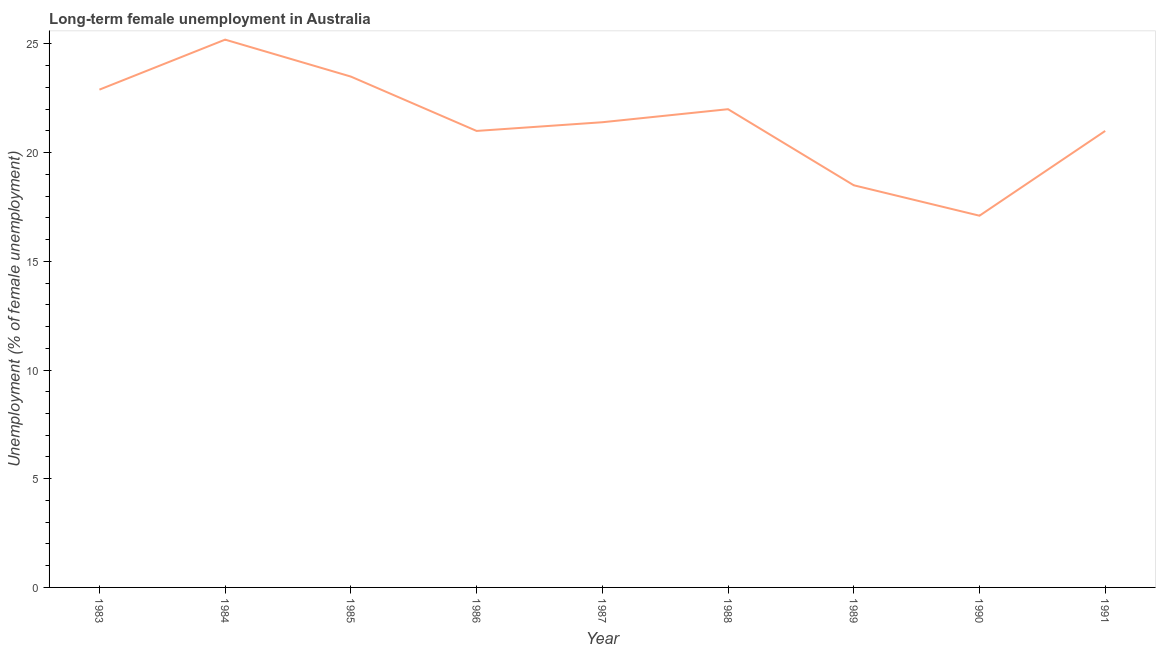What is the long-term female unemployment in 1987?
Your answer should be compact. 21.4. Across all years, what is the maximum long-term female unemployment?
Offer a terse response. 25.2. Across all years, what is the minimum long-term female unemployment?
Your answer should be very brief. 17.1. In which year was the long-term female unemployment maximum?
Provide a succinct answer. 1984. In which year was the long-term female unemployment minimum?
Your answer should be very brief. 1990. What is the sum of the long-term female unemployment?
Make the answer very short. 192.6. What is the difference between the long-term female unemployment in 1984 and 1989?
Provide a short and direct response. 6.7. What is the average long-term female unemployment per year?
Your answer should be compact. 21.4. What is the median long-term female unemployment?
Offer a terse response. 21.4. What is the ratio of the long-term female unemployment in 1986 to that in 1987?
Your answer should be compact. 0.98. What is the difference between the highest and the second highest long-term female unemployment?
Keep it short and to the point. 1.7. What is the difference between the highest and the lowest long-term female unemployment?
Offer a terse response. 8.1. Does the long-term female unemployment monotonically increase over the years?
Give a very brief answer. No. How many lines are there?
Offer a very short reply. 1. How many years are there in the graph?
Make the answer very short. 9. What is the difference between two consecutive major ticks on the Y-axis?
Your response must be concise. 5. Does the graph contain grids?
Keep it short and to the point. No. What is the title of the graph?
Your response must be concise. Long-term female unemployment in Australia. What is the label or title of the X-axis?
Your response must be concise. Year. What is the label or title of the Y-axis?
Your response must be concise. Unemployment (% of female unemployment). What is the Unemployment (% of female unemployment) of 1983?
Offer a terse response. 22.9. What is the Unemployment (% of female unemployment) in 1984?
Provide a short and direct response. 25.2. What is the Unemployment (% of female unemployment) of 1986?
Keep it short and to the point. 21. What is the Unemployment (% of female unemployment) of 1987?
Keep it short and to the point. 21.4. What is the Unemployment (% of female unemployment) in 1989?
Provide a short and direct response. 18.5. What is the Unemployment (% of female unemployment) of 1990?
Your answer should be very brief. 17.1. What is the Unemployment (% of female unemployment) in 1991?
Give a very brief answer. 21. What is the difference between the Unemployment (% of female unemployment) in 1983 and 1985?
Keep it short and to the point. -0.6. What is the difference between the Unemployment (% of female unemployment) in 1983 and 1988?
Your answer should be very brief. 0.9. What is the difference between the Unemployment (% of female unemployment) in 1983 and 1989?
Keep it short and to the point. 4.4. What is the difference between the Unemployment (% of female unemployment) in 1984 and 1985?
Your answer should be compact. 1.7. What is the difference between the Unemployment (% of female unemployment) in 1984 and 1986?
Provide a short and direct response. 4.2. What is the difference between the Unemployment (% of female unemployment) in 1984 and 1987?
Provide a short and direct response. 3.8. What is the difference between the Unemployment (% of female unemployment) in 1984 and 1989?
Your response must be concise. 6.7. What is the difference between the Unemployment (% of female unemployment) in 1985 and 1986?
Your answer should be very brief. 2.5. What is the difference between the Unemployment (% of female unemployment) in 1985 and 1990?
Your answer should be compact. 6.4. What is the difference between the Unemployment (% of female unemployment) in 1986 and 1990?
Offer a very short reply. 3.9. What is the difference between the Unemployment (% of female unemployment) in 1986 and 1991?
Make the answer very short. 0. What is the difference between the Unemployment (% of female unemployment) in 1987 and 1990?
Your answer should be very brief. 4.3. What is the difference between the Unemployment (% of female unemployment) in 1988 and 1989?
Ensure brevity in your answer.  3.5. What is the difference between the Unemployment (% of female unemployment) in 1988 and 1991?
Give a very brief answer. 1. What is the difference between the Unemployment (% of female unemployment) in 1989 and 1991?
Provide a succinct answer. -2.5. What is the ratio of the Unemployment (% of female unemployment) in 1983 to that in 1984?
Ensure brevity in your answer.  0.91. What is the ratio of the Unemployment (% of female unemployment) in 1983 to that in 1985?
Your answer should be compact. 0.97. What is the ratio of the Unemployment (% of female unemployment) in 1983 to that in 1986?
Ensure brevity in your answer.  1.09. What is the ratio of the Unemployment (% of female unemployment) in 1983 to that in 1987?
Provide a succinct answer. 1.07. What is the ratio of the Unemployment (% of female unemployment) in 1983 to that in 1988?
Keep it short and to the point. 1.04. What is the ratio of the Unemployment (% of female unemployment) in 1983 to that in 1989?
Offer a very short reply. 1.24. What is the ratio of the Unemployment (% of female unemployment) in 1983 to that in 1990?
Give a very brief answer. 1.34. What is the ratio of the Unemployment (% of female unemployment) in 1983 to that in 1991?
Provide a short and direct response. 1.09. What is the ratio of the Unemployment (% of female unemployment) in 1984 to that in 1985?
Your answer should be compact. 1.07. What is the ratio of the Unemployment (% of female unemployment) in 1984 to that in 1986?
Ensure brevity in your answer.  1.2. What is the ratio of the Unemployment (% of female unemployment) in 1984 to that in 1987?
Provide a short and direct response. 1.18. What is the ratio of the Unemployment (% of female unemployment) in 1984 to that in 1988?
Keep it short and to the point. 1.15. What is the ratio of the Unemployment (% of female unemployment) in 1984 to that in 1989?
Provide a short and direct response. 1.36. What is the ratio of the Unemployment (% of female unemployment) in 1984 to that in 1990?
Offer a terse response. 1.47. What is the ratio of the Unemployment (% of female unemployment) in 1984 to that in 1991?
Offer a terse response. 1.2. What is the ratio of the Unemployment (% of female unemployment) in 1985 to that in 1986?
Provide a short and direct response. 1.12. What is the ratio of the Unemployment (% of female unemployment) in 1985 to that in 1987?
Ensure brevity in your answer.  1.1. What is the ratio of the Unemployment (% of female unemployment) in 1985 to that in 1988?
Make the answer very short. 1.07. What is the ratio of the Unemployment (% of female unemployment) in 1985 to that in 1989?
Offer a terse response. 1.27. What is the ratio of the Unemployment (% of female unemployment) in 1985 to that in 1990?
Keep it short and to the point. 1.37. What is the ratio of the Unemployment (% of female unemployment) in 1985 to that in 1991?
Provide a succinct answer. 1.12. What is the ratio of the Unemployment (% of female unemployment) in 1986 to that in 1988?
Offer a very short reply. 0.95. What is the ratio of the Unemployment (% of female unemployment) in 1986 to that in 1989?
Ensure brevity in your answer.  1.14. What is the ratio of the Unemployment (% of female unemployment) in 1986 to that in 1990?
Provide a short and direct response. 1.23. What is the ratio of the Unemployment (% of female unemployment) in 1987 to that in 1988?
Give a very brief answer. 0.97. What is the ratio of the Unemployment (% of female unemployment) in 1987 to that in 1989?
Offer a terse response. 1.16. What is the ratio of the Unemployment (% of female unemployment) in 1987 to that in 1990?
Provide a succinct answer. 1.25. What is the ratio of the Unemployment (% of female unemployment) in 1988 to that in 1989?
Provide a succinct answer. 1.19. What is the ratio of the Unemployment (% of female unemployment) in 1988 to that in 1990?
Make the answer very short. 1.29. What is the ratio of the Unemployment (% of female unemployment) in 1988 to that in 1991?
Provide a short and direct response. 1.05. What is the ratio of the Unemployment (% of female unemployment) in 1989 to that in 1990?
Your answer should be very brief. 1.08. What is the ratio of the Unemployment (% of female unemployment) in 1989 to that in 1991?
Keep it short and to the point. 0.88. What is the ratio of the Unemployment (% of female unemployment) in 1990 to that in 1991?
Keep it short and to the point. 0.81. 